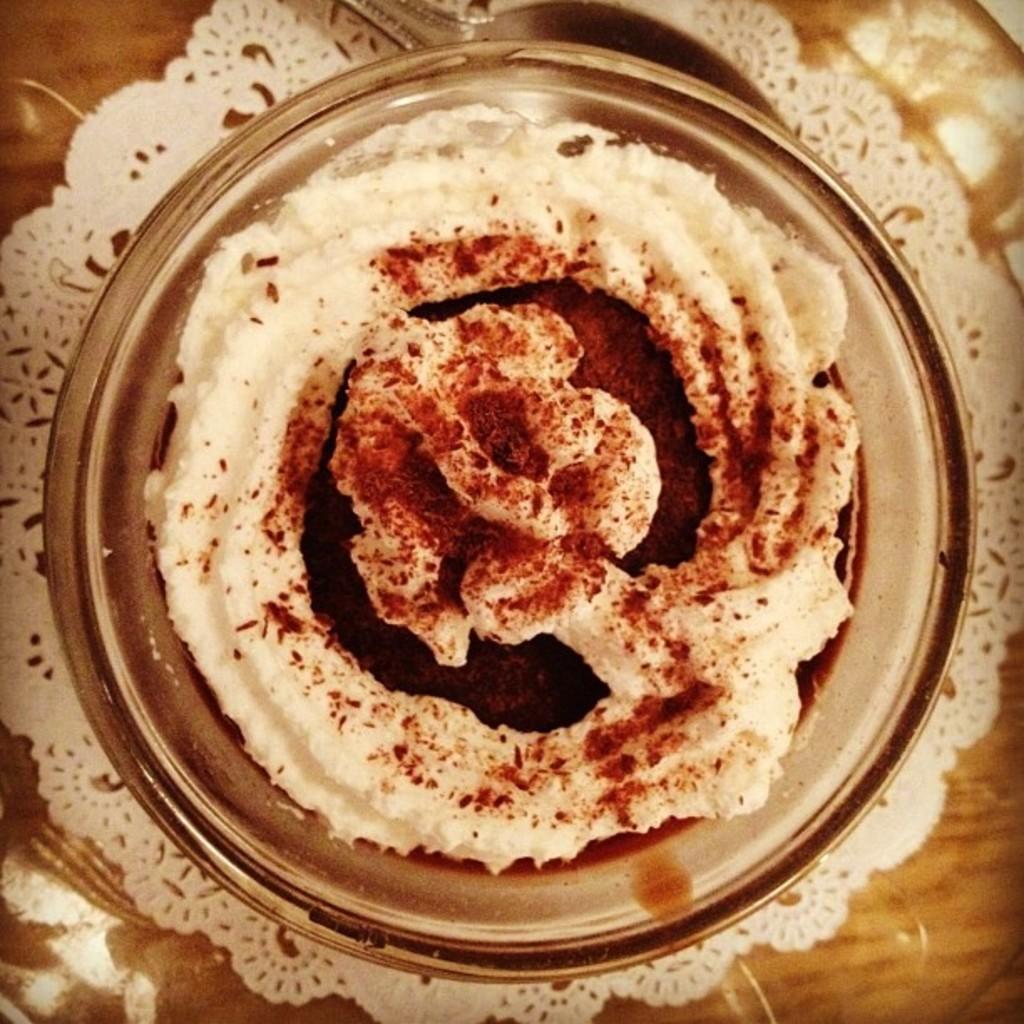In one or two sentences, can you explain what this image depicts? Here we can see a food item in a bowl on a dining mat on the table. 